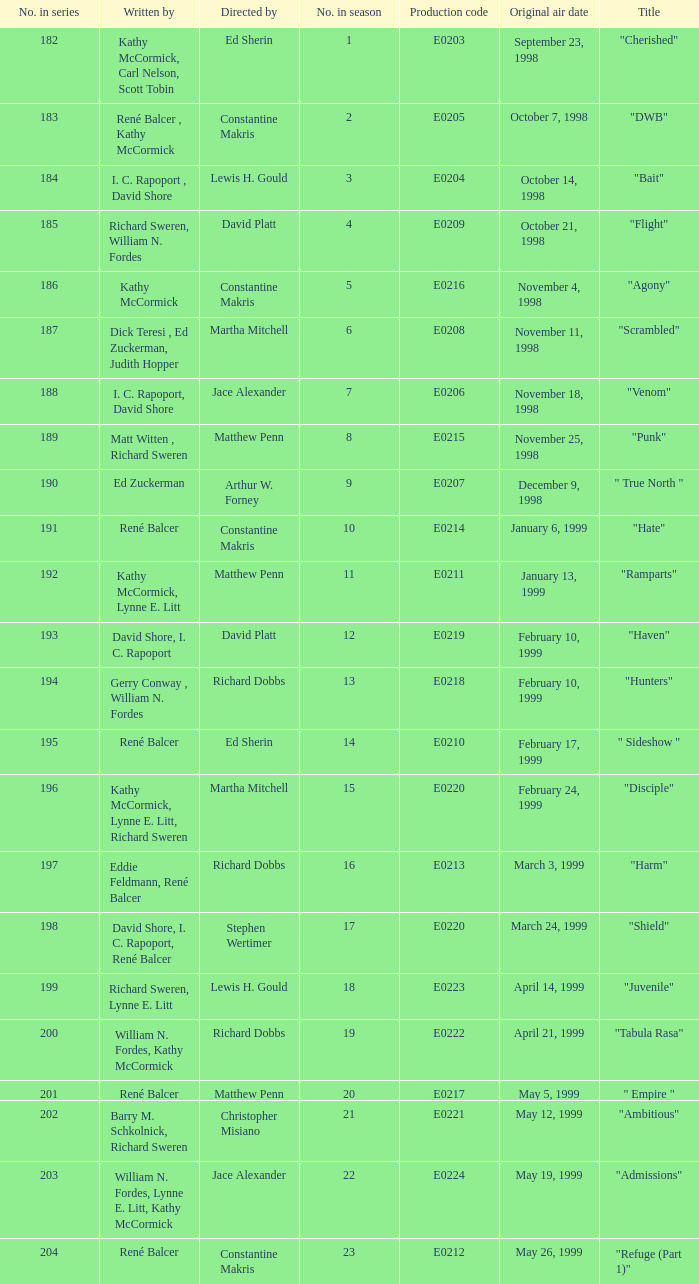On what date was the episode titled "bait" first broadcasted? October 14, 1998. 